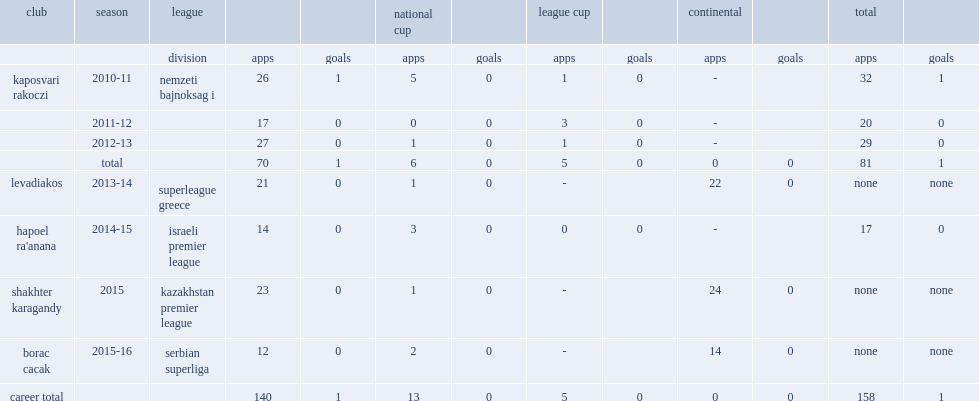Which club did pedro sass petrazzi play for in 2015? Shakhter karagandy. 